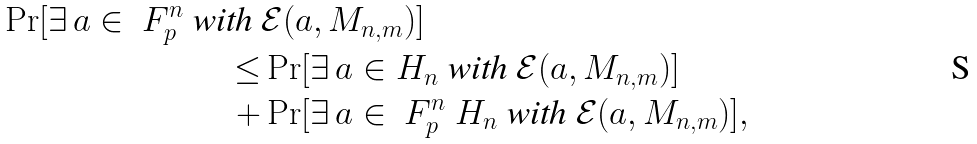Convert formula to latex. <formula><loc_0><loc_0><loc_500><loc_500>\Pr [ \exists \, a \in \ F _ { p } ^ { n } \text { with } & \mathcal { E } ( a , M _ { n , m } ) ] \\ \leq & \Pr [ \exists \, a \in H _ { n } \text { with } \mathcal { E } ( a , M _ { n , m } ) ] \\ + & \Pr [ \exists \, a \in \ F _ { p } ^ { n } \ H _ { n } \text { with } \mathcal { E } ( a , M _ { n , m } ) ] ,</formula> 